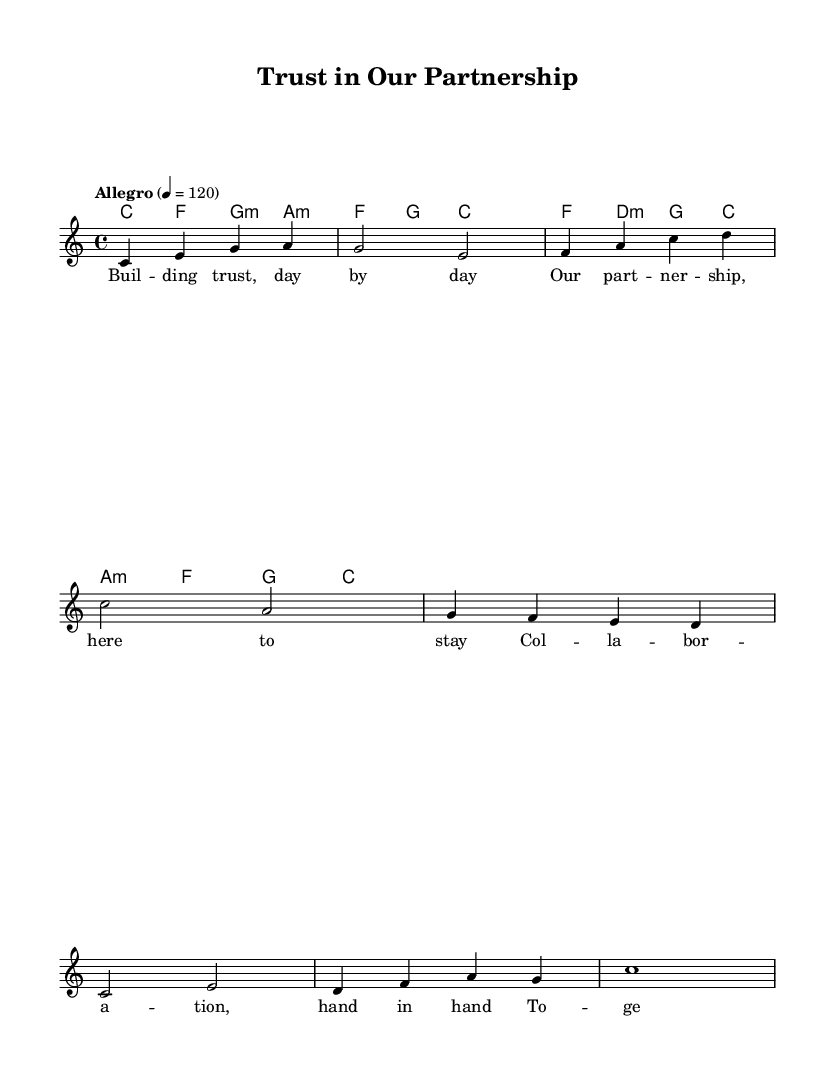What is the key signature of this music? The key signature is C major, which has no sharps or flats.
Answer: C major What is the time signature of this music? The time signature is indicated as 4/4, meaning there are four beats in each measure.
Answer: 4/4 What is the tempo designation for this piece? The tempo is marked as "Allegro," which indicates a fast and lively pace, specifically set at 120 beats per minute.
Answer: Allegro How many measures are in the melody section? By counting from the beginning to the end of the melody, there are eight measures present.
Answer: Eight What is the first lyric line of the verse? The first lyric line of the verse is "Building trust, day by day," which establishes the theme of collaboration.
Answer: Building trust, day by day Which chord is played with the lyrics "collaboration, hand in hand"? The chord corresponding to this lyric section is a C major chord, indicating the harmonic foundation for the phrase.
Answer: C major What is the last note of the melody? The last note of the melody is a whole note "c," marking the end of the musical phrase in measure eight.
Answer: C 